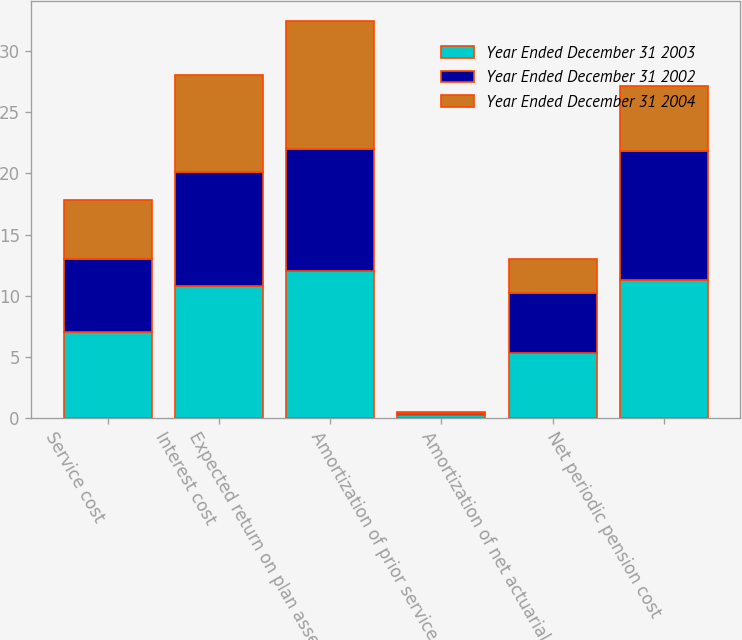Convert chart to OTSL. <chart><loc_0><loc_0><loc_500><loc_500><stacked_bar_chart><ecel><fcel>Service cost<fcel>Interest cost<fcel>Expected return on plan assets<fcel>Amortization of prior service<fcel>Amortization of net actuarial<fcel>Net periodic pension cost<nl><fcel>Year Ended December 31 2003<fcel>7<fcel>10.8<fcel>12<fcel>0.2<fcel>5.3<fcel>11.3<nl><fcel>Year Ended December 31 2002<fcel>6<fcel>9.3<fcel>10<fcel>0.2<fcel>4.9<fcel>10.5<nl><fcel>Year Ended December 31 2004<fcel>4.8<fcel>8<fcel>10.5<fcel>0.1<fcel>2.8<fcel>5.4<nl></chart> 